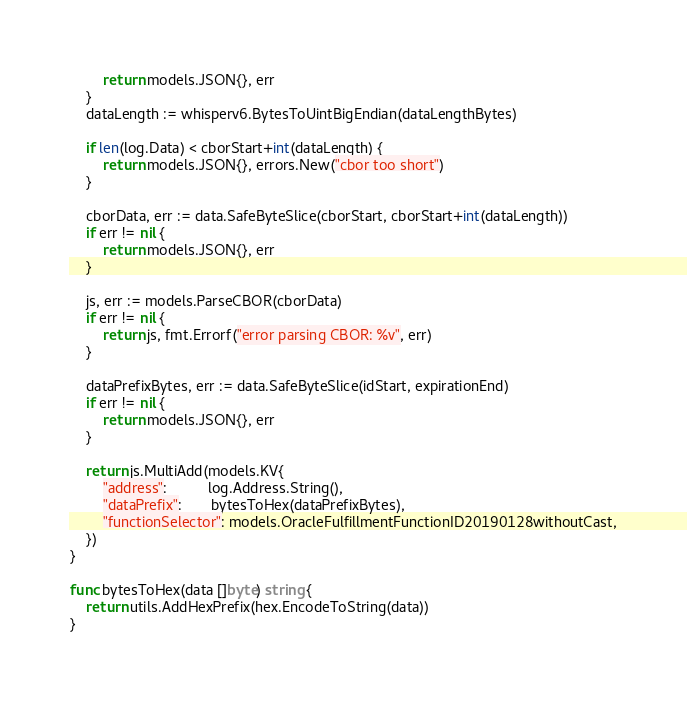Convert code to text. <code><loc_0><loc_0><loc_500><loc_500><_Go_>		return models.JSON{}, err
	}
	dataLength := whisperv6.BytesToUintBigEndian(dataLengthBytes)

	if len(log.Data) < cborStart+int(dataLength) {
		return models.JSON{}, errors.New("cbor too short")
	}

	cborData, err := data.SafeByteSlice(cborStart, cborStart+int(dataLength))
	if err != nil {
		return models.JSON{}, err
	}

	js, err := models.ParseCBOR(cborData)
	if err != nil {
		return js, fmt.Errorf("error parsing CBOR: %v", err)
	}

	dataPrefixBytes, err := data.SafeByteSlice(idStart, expirationEnd)
	if err != nil {
		return models.JSON{}, err
	}

	return js.MultiAdd(models.KV{
		"address":          log.Address.String(),
		"dataPrefix":       bytesToHex(dataPrefixBytes),
		"functionSelector": models.OracleFulfillmentFunctionID20190128withoutCast,
	})
}

func bytesToHex(data []byte) string {
	return utils.AddHexPrefix(hex.EncodeToString(data))
}
</code> 